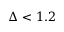<formula> <loc_0><loc_0><loc_500><loc_500>\Delta < 1 . 2</formula> 